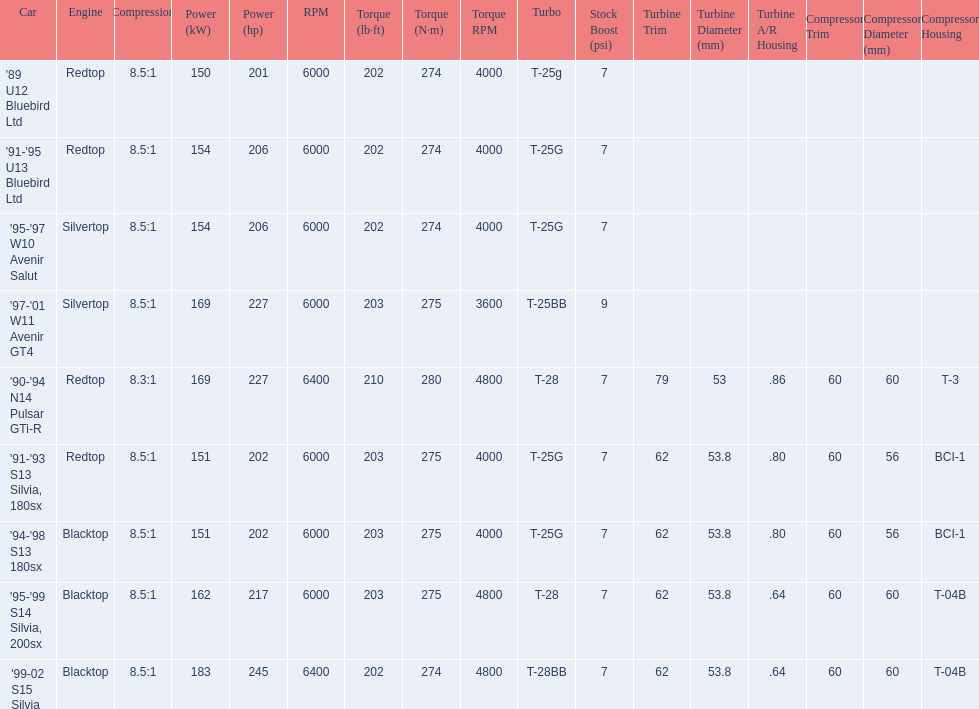Which of the cars uses the redtop engine? '89 U12 Bluebird Ltd, '91-'95 U13 Bluebird Ltd, '90-'94 N14 Pulsar GTi-R, '91-'93 S13 Silvia, 180sx. Of these, has more than 220 horsepower? '90-'94 N14 Pulsar GTi-R. What is the compression ratio of this car? 8.3:1. 